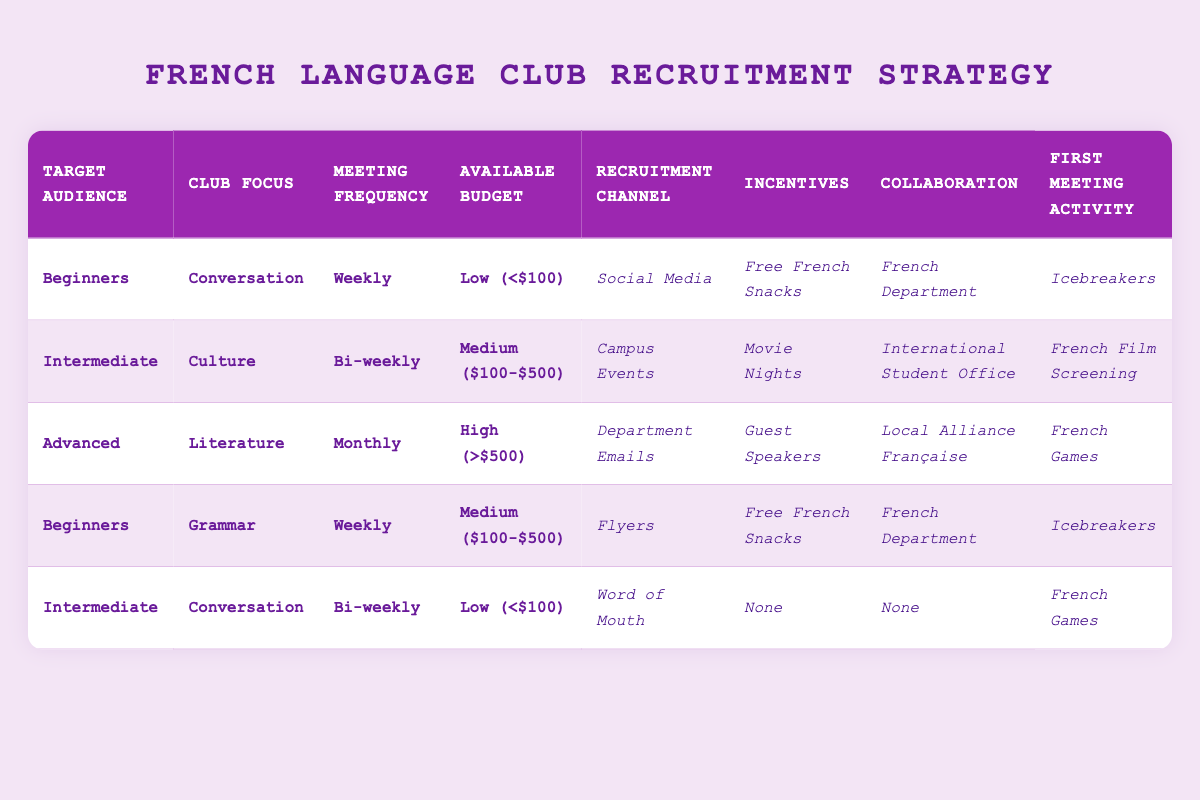What recruitment channel is used for Advanced learners focusing on Literature? The row for Advanced learners focusing on Literature specifies that the Recruitment Channel is Department Emails.
Answer: Department Emails Which meeting frequency is paired with the Intermediate audience focusing on Culture? The rule for Intermediate learners focusing on Culture indicates that the Meeting Frequency is Bi-weekly.
Answer: Bi-weekly Are Free French Snacks offered as an incentive for all events in the table? In the table, Free French Snacks are offered as an incentive only for two specific scenarios: Beginners focusing on Conversation and Beginners focusing on Grammar. Hence, it is not true that it is available for all events.
Answer: No What is the recruitment channel for Beginners focusing on Grammar with a Medium budget? The row specifies that the recruitment channel for Beginners focusing on Grammar and a Medium budget is Flyers.
Answer: Flyers What is the average Available Budget across all categories in the table? The budgets listed are Low (<$100), Medium ($100-$500), and High (>$500). Assigning numerical values, Low = 50, Medium = 300, and High = 750. To find the average: (50 + 300 + 750 + 300 + 50)/5 = 290. Thus, the average is 290.
Answer: 290 What is the collaboration noted for Intermediate learners focusing on Conversation with a Low budget? The table indicates that Intermediate learners focusing on Conversation with a Low budget have no collaboration specified, identified as "None."
Answer: None Which audience has the lowest meeting frequency in the strategies provided? The lowest meeting frequency in the table is "Monthly," which is assigned only to Advanced learners focusing on Literature.
Answer: Advanced Is there any scenario in the table where the First Meeting Activity is a French Film Screening? Yes, there is a scenario where the First Meeting Activity is a French Film Screening for Intermediate learners focusing on Culture.
Answer: Yes What incentives are offered when the Target Audience is Intermediate focusing on Conversation with a Low budget? According to the table, the Incentives for Intermediate learners focusing on Conversation with a Low budget is "None."
Answer: None What is the First Meeting Activity for Beginners focusing on Conversation? The table shows that the First Meeting Activity for Beginners focusing on Conversation is Icebreakers.
Answer: Icebreakers 